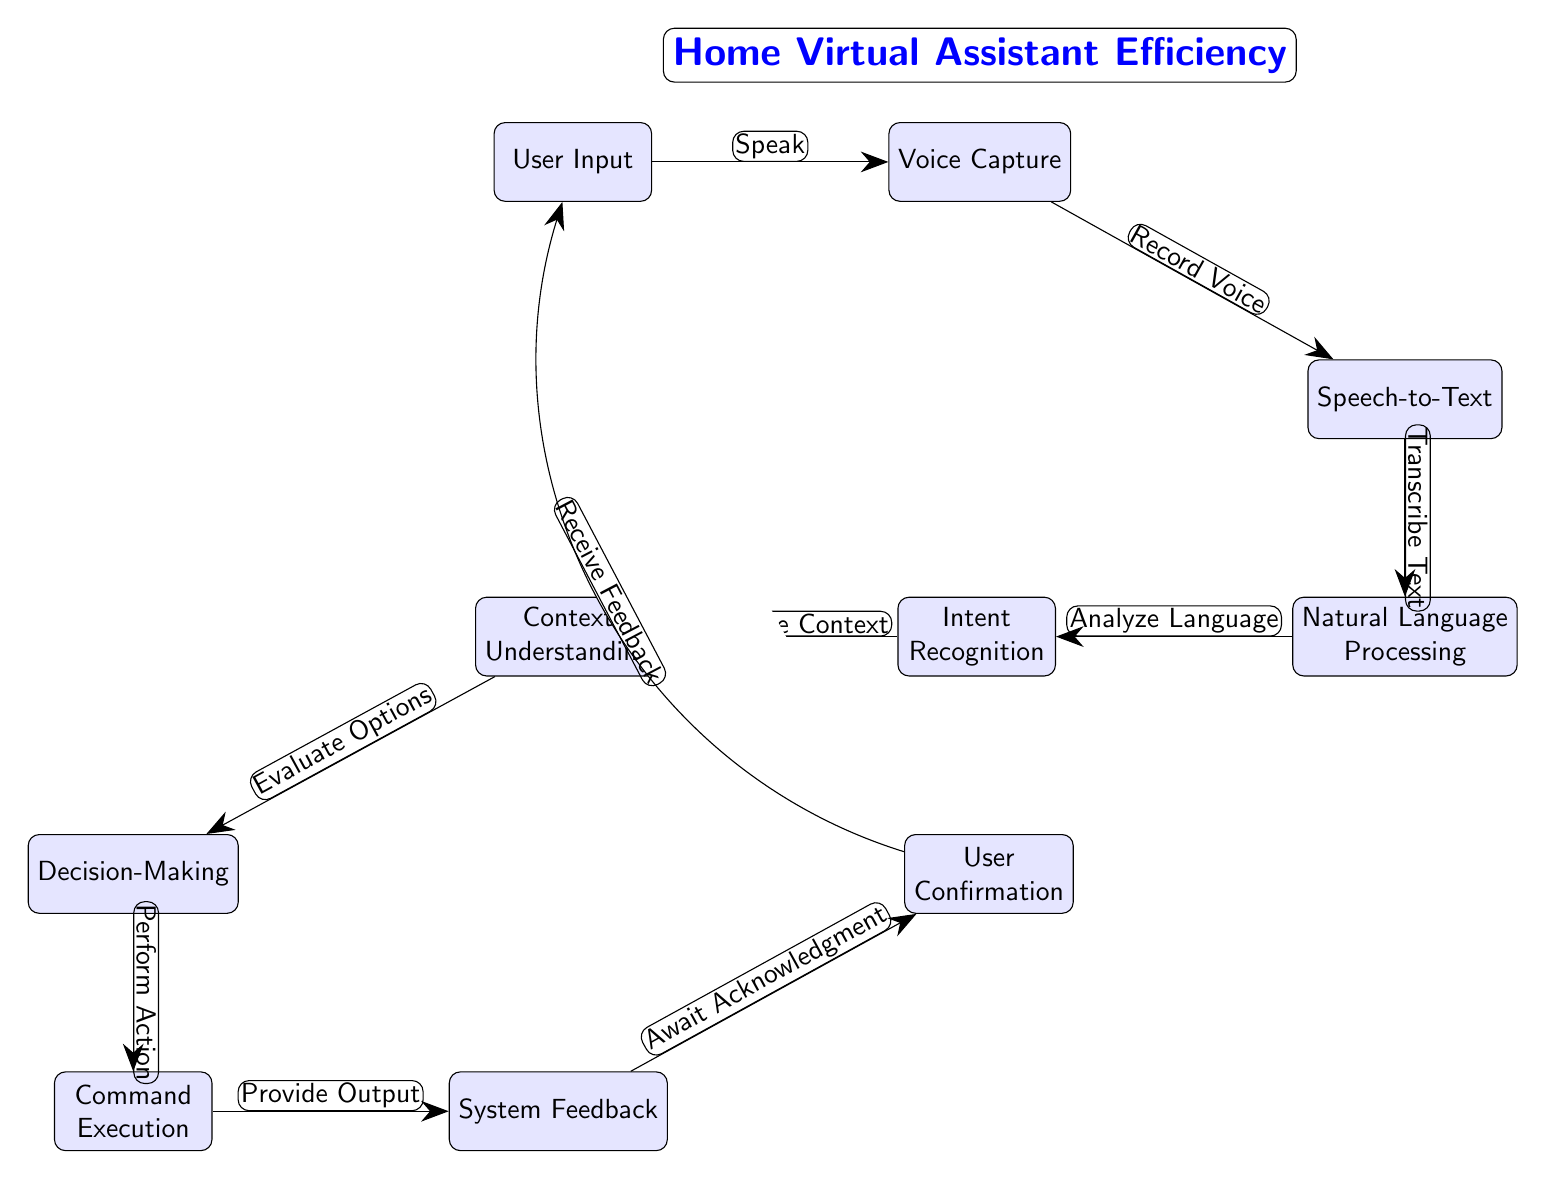What is the first step in the diagram? The first step, starting from the user input, is 'Voice Capture,' which indicates that the process begins with capturing the user's spoken command.
Answer: Voice Capture How many primary nodes are there in the diagram? Counting each distinct node, there are a total of ten primary nodes that represent various stages in the virtual assistant process.
Answer: Ten What does the 'Natural Language Processing' node receive as input? 'Natural Language Processing' receives its input from the 'Speech-to-Text' node, processing the transcribed text generated from the user's spoken words.
Answer: Speech-to-Text What is the output of the 'Command Execution' node? The output of the 'Command Execution' node is 'System Feedback,' which indicates that after executing the appropriate command, the system provides feedback to the user.
Answer: System Feedback Which node is responsible for determining the context? The 'Context Understanding' node is responsible for determining the context within which the user's command is given, facilitating more accurate responses from the system.
Answer: Context Understanding How does the diagram demonstrate a feedback loop? The diagram shows a feedback loop by connecting 'User Confirmation' back to 'User Input,' indicating that the system awaits feedback and may adjust its actions based on user responses.
Answer: Receive Feedback What action is performed after 'Evaluate Options'? After 'Evaluate Options,' the next action performed is 'Decision-Making,' where the assistant decides the most appropriate response or action based on the evaluated options.
Answer: Decision-Making What is the label for the edge connecting 'Context Understanding' to 'Decision-Making'? The label for the edge connecting these two nodes is 'Evaluate Options,' which explains that the context helps determine the best options before making a decision.
Answer: Evaluate Options What is the relationship between 'Speech-to-Text' and 'Natural Language Processing'? The relationship is a sequential one, where 'Speech-to-Text' transcribes the voice input into written form, which 'Natural Language Processing' then analyzes for intent and meaning.
Answer: Speech-to-Text to Natural Language Processing 